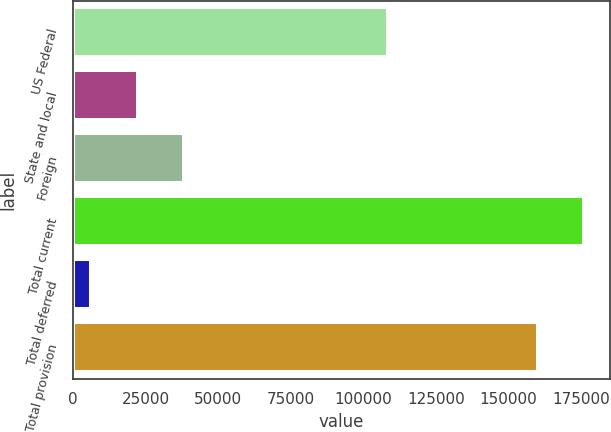Convert chart. <chart><loc_0><loc_0><loc_500><loc_500><bar_chart><fcel>US Federal<fcel>State and local<fcel>Foreign<fcel>Total current<fcel>Total deferred<fcel>Total provision<nl><fcel>108540<fcel>22227<fcel>38233.9<fcel>176076<fcel>6051<fcel>160069<nl></chart> 